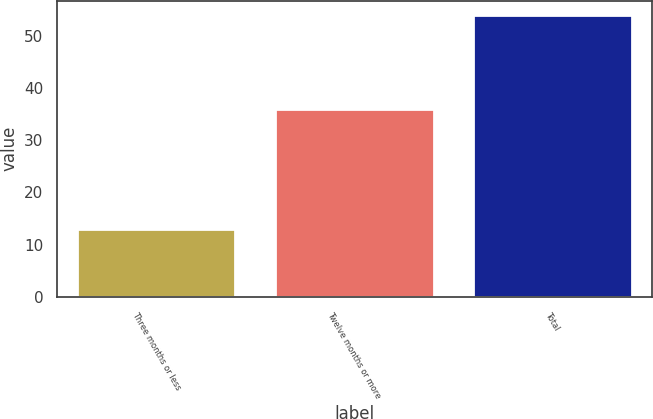<chart> <loc_0><loc_0><loc_500><loc_500><bar_chart><fcel>Three months or less<fcel>Twelve months or more<fcel>Total<nl><fcel>13<fcel>36<fcel>54<nl></chart> 